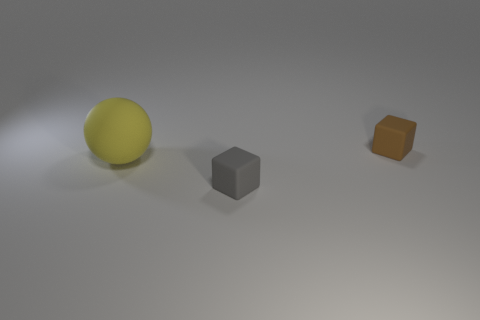Add 1 matte things. How many objects exist? 4 Subtract all balls. How many objects are left? 2 Add 2 gray matte cubes. How many gray matte cubes are left? 3 Add 3 big things. How many big things exist? 4 Subtract 0 purple blocks. How many objects are left? 3 Subtract all brown matte things. Subtract all small blocks. How many objects are left? 0 